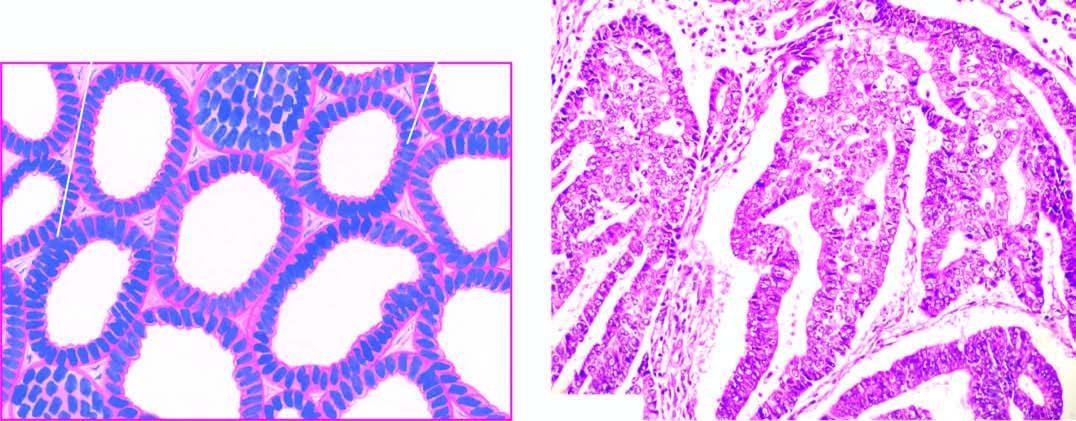s the most common histologic pattern well-differentiated adenocarcinoma showing closely packed glands with cytologic atypia?
Answer the question using a single word or phrase. Yes 